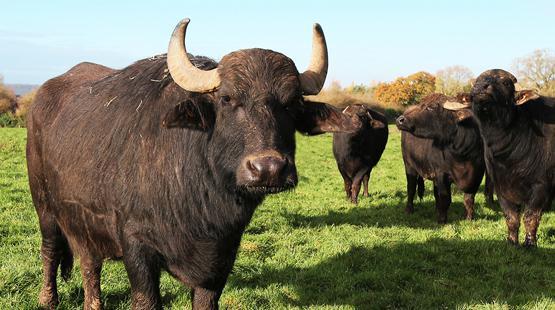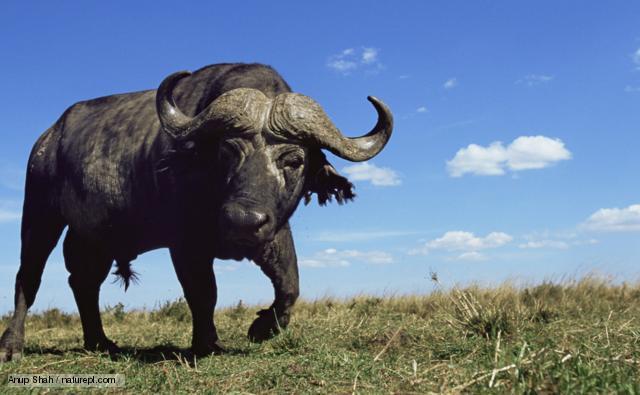The first image is the image on the left, the second image is the image on the right. Assess this claim about the two images: "All the animals have horns.". Correct or not? Answer yes or no. Yes. 